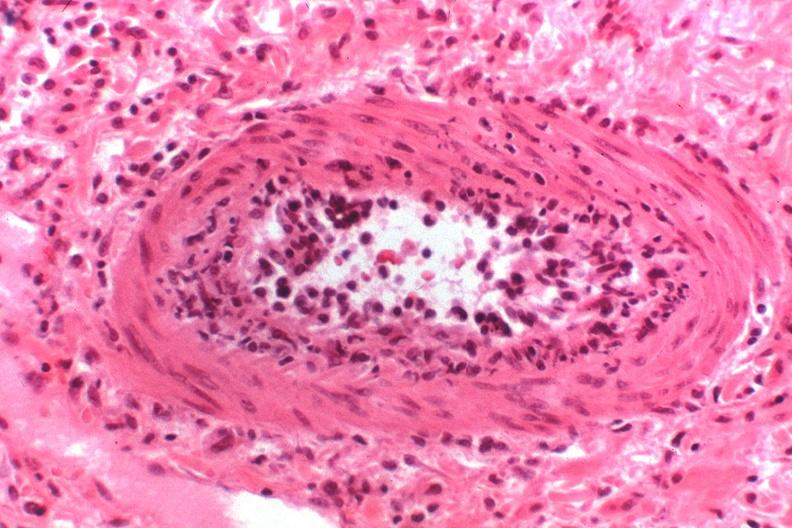does conjoined twins show kidney transplant rejection?
Answer the question using a single word or phrase. No 